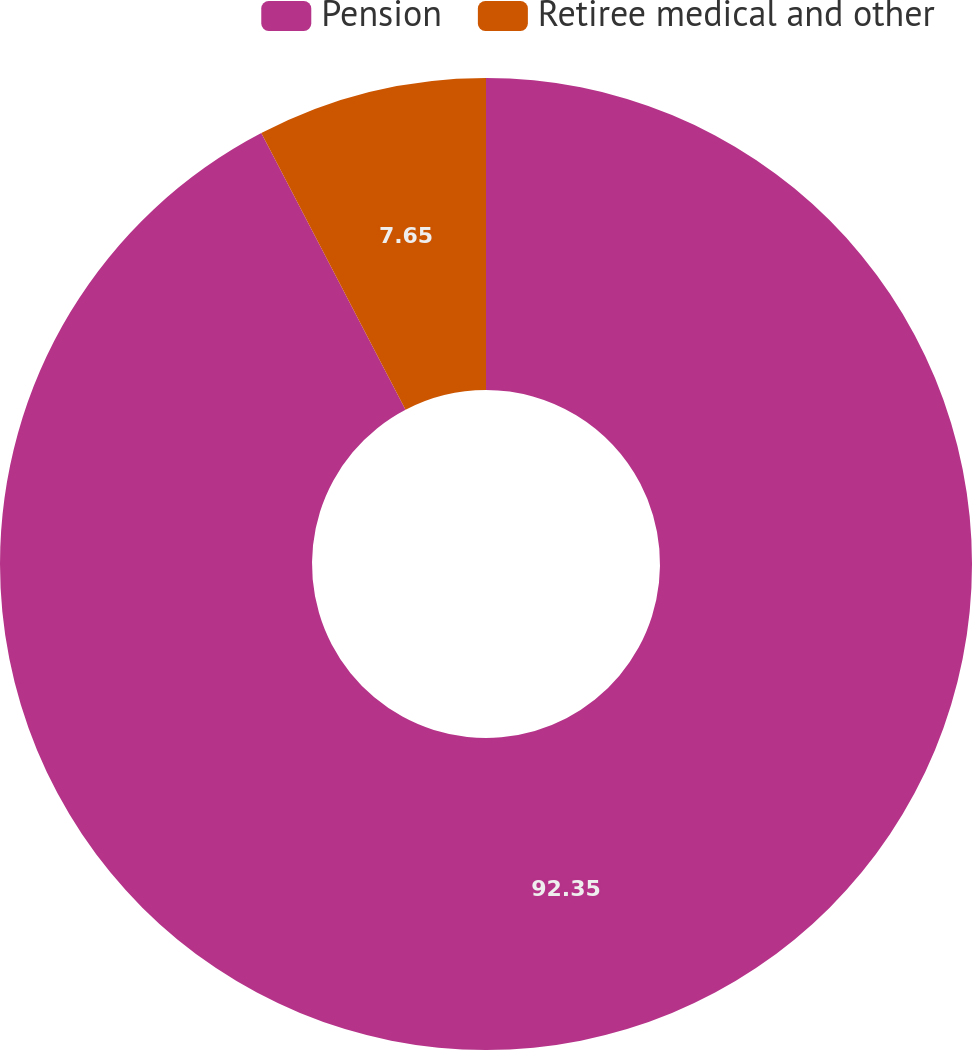Convert chart to OTSL. <chart><loc_0><loc_0><loc_500><loc_500><pie_chart><fcel>Pension<fcel>Retiree medical and other<nl><fcel>92.35%<fcel>7.65%<nl></chart> 